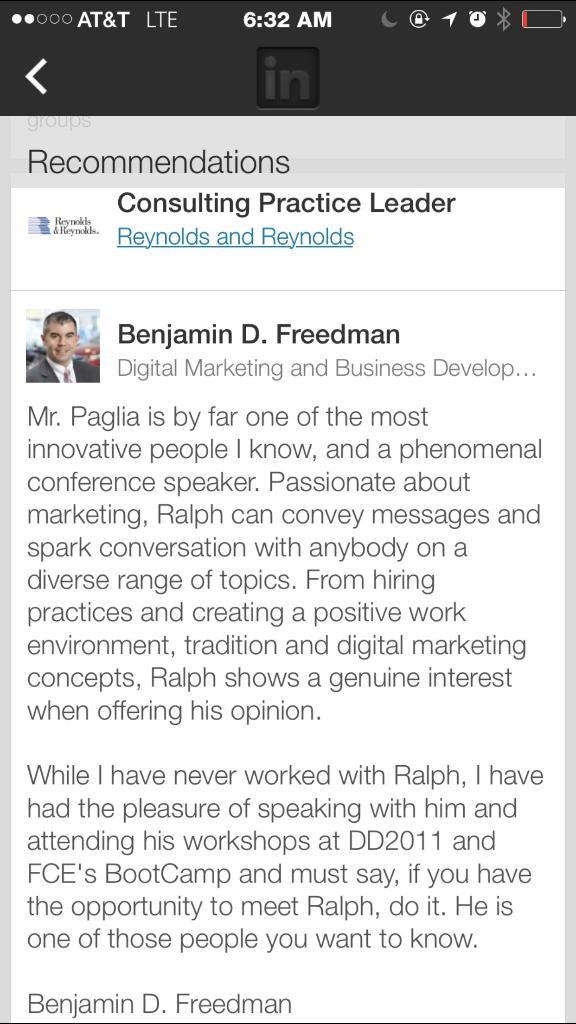What is the main subject of the image? The main subject of the image is a screenshot. Can you describe the content of the screenshot? There is text visible within the screenshot. What type of toothpaste is being advertised in the image? There is no toothpaste or advertisement present in the image; it is a screenshot with text. Can you see a monkey holding an icicle in the image? There is no monkey or icicle present in the image; it is a screenshot with text. 